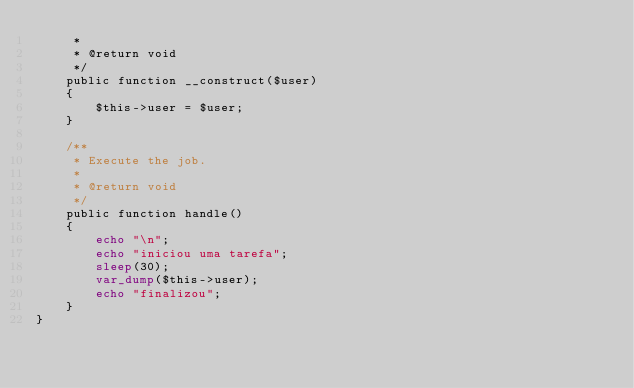<code> <loc_0><loc_0><loc_500><loc_500><_PHP_>     *
     * @return void
     */
    public function __construct($user)
    {
        $this->user = $user;
    }

    /**
     * Execute the job.
     *
     * @return void
     */
    public function handle()
    {
        echo "\n";
        echo "iniciou uma tarefa";
        sleep(30);
        var_dump($this->user);
        echo "finalizou";
    }
}
</code> 